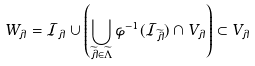Convert formula to latex. <formula><loc_0><loc_0><loc_500><loc_500>W _ { \lambda } = \mathcal { I } _ { \lambda } \cup \left ( \bigcup _ { \widetilde { \lambda } \in \widetilde { \Lambda } } \varphi ^ { - 1 } ( \mathcal { I } _ { \widetilde { \lambda } } ) \cap V _ { \lambda } \right ) \subset V _ { \lambda }</formula> 